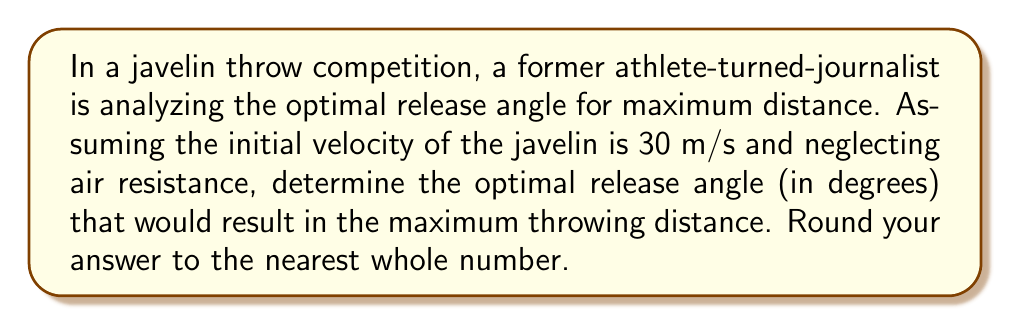Solve this math problem. To solve this problem, we'll use the principles of projectile motion and optimization. The range (R) of a projectile launched from ground level is given by the equation:

$$ R = \frac{v_0^2 \sin(2\theta)}{g} $$

Where:
$v_0$ is the initial velocity
$\theta$ is the launch angle
$g$ is the acceleration due to gravity (9.8 m/s²)

To find the optimal angle, we need to maximize this function. The maximum occurs when $\sin(2\theta)$ is at its maximum value, which is 1. This happens when:

$$ 2\theta = 90° $$

Solving for $\theta$:

$$ \theta = 45° $$

This result shows that, in theory, the optimal launch angle for maximum distance is always 45° when launching from and landing on the same horizontal plane, regardless of the initial velocity.

However, in real-world scenarios, factors such as air resistance, the aerodynamics of the javelin, and the height of release can slightly alter this optimal angle. These factors often result in a slightly lower optimal angle, typically between 35° and 45°.

For the purposes of this idealized problem (neglecting air resistance), we'll use the theoretical optimal angle of 45°.

To verify, we can calculate the distance using this angle:

$$ R = \frac{(30 \text{ m/s})^2 \sin(2 * 45°)}{9.8 \text{ m/s}^2} $$
$$ R = \frac{900 \text{ m}^2 * 1}{9.8 \text{ m/s}^2} $$
$$ R \approx 91.84 \text{ m} $$

This is indeed the maximum distance achievable under these conditions.
Answer: 45° 